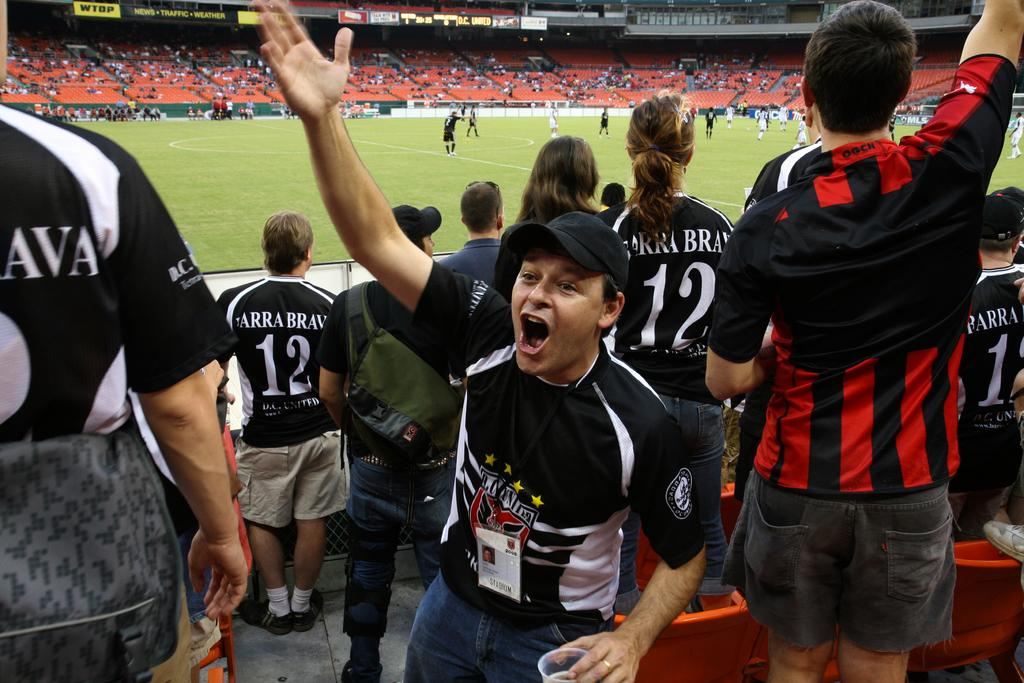<image>
Give a short and clear explanation of the subsequent image. At least three people are wearing jerseys with the number 12 on them in this crowd. 